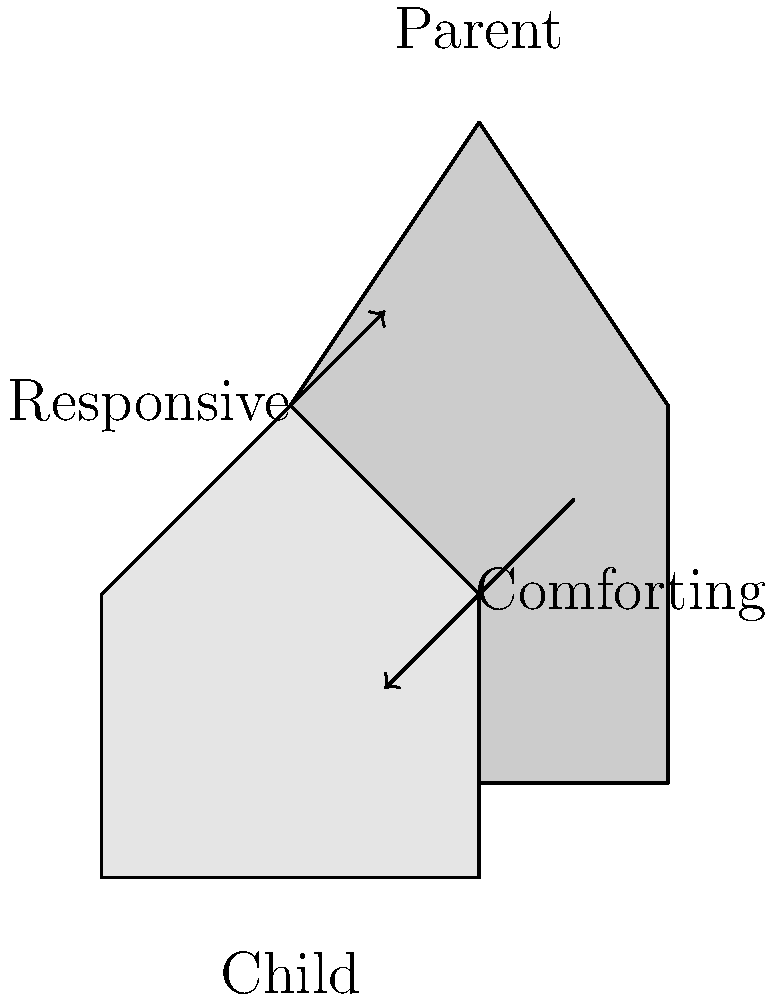Based on the illustrated parent-child interaction, which attachment style is most likely being demonstrated? To determine the attachment style, we need to analyze the parent-child interaction depicted in the illustration:

1. Parent's position: The parent figure is positioned above and slightly to the side of the child, indicating a protective and nurturing stance.

2. Arrows: There are two arrows in the illustration:
   a) One pointing from the child towards the parent, labeled "Responsive"
   b) Another pointing from the parent towards the child, labeled "Comforting"

3. Interpretation of arrows:
   - The "Responsive" arrow suggests that the child is seeking attention or support from the parent.
   - The "Comforting" arrow indicates that the parent is providing comfort and support in response to the child's needs.

4. Attachment styles:
   - Secure: Characterized by responsive, consistent caregiving
   - Anxious: Characterized by inconsistent caregiving
   - Avoidant: Characterized by unresponsive or rejecting caregiving
   - Disorganized: Characterized by frightening or unpredictable caregiving

5. Analysis:
   The interaction shown depicts a responsive parent providing comfort to the child. This reciprocal, positive interaction is a hallmark of secure attachment.

Therefore, the attachment style most likely being demonstrated in this illustration is secure attachment.
Answer: Secure attachment 